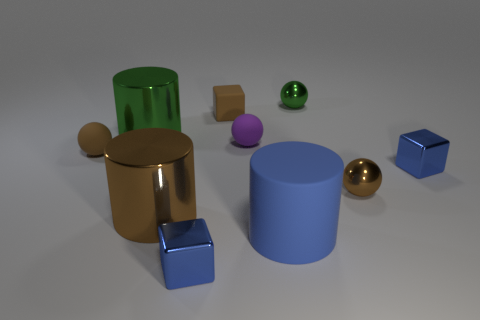There is a green metal object that is right of the brown shiny cylinder; what size is it?
Your answer should be very brief. Small. Are there any brown objects that have the same material as the big blue object?
Keep it short and to the point. Yes. What number of big green things are the same shape as the blue rubber thing?
Provide a succinct answer. 1. What is the shape of the brown thing that is on the right side of the metallic sphere that is behind the blue metallic object to the right of the tiny green object?
Offer a very short reply. Sphere. What material is the small thing that is both right of the brown matte cube and to the left of the blue matte thing?
Make the answer very short. Rubber. Is the size of the green shiny thing right of the blue cylinder the same as the green shiny cylinder?
Offer a very short reply. No. Is there any other thing that has the same size as the purple matte object?
Ensure brevity in your answer.  Yes. Is the number of small blue shiny things in front of the tiny brown metallic sphere greater than the number of small purple objects behind the big green cylinder?
Offer a terse response. Yes. What is the color of the metal cylinder that is behind the small blue block on the right side of the small shiny thing that is in front of the big rubber cylinder?
Ensure brevity in your answer.  Green. There is a big cylinder in front of the large brown cylinder; is its color the same as the rubber cube?
Keep it short and to the point. No. 